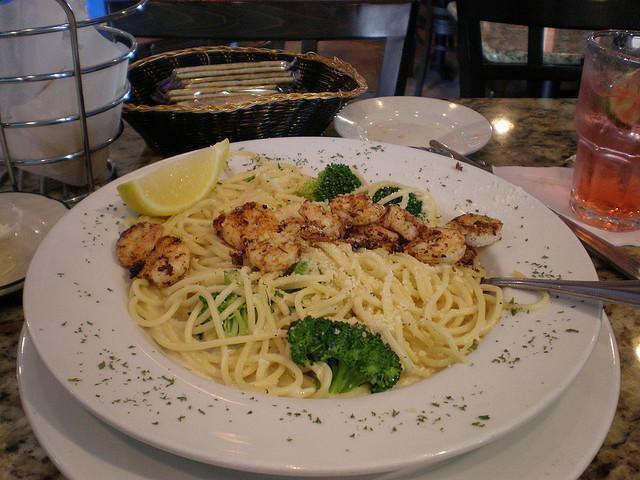How many candles are illuminated?
Give a very brief answer. 0. How many cups are visible?
Give a very brief answer. 1. 